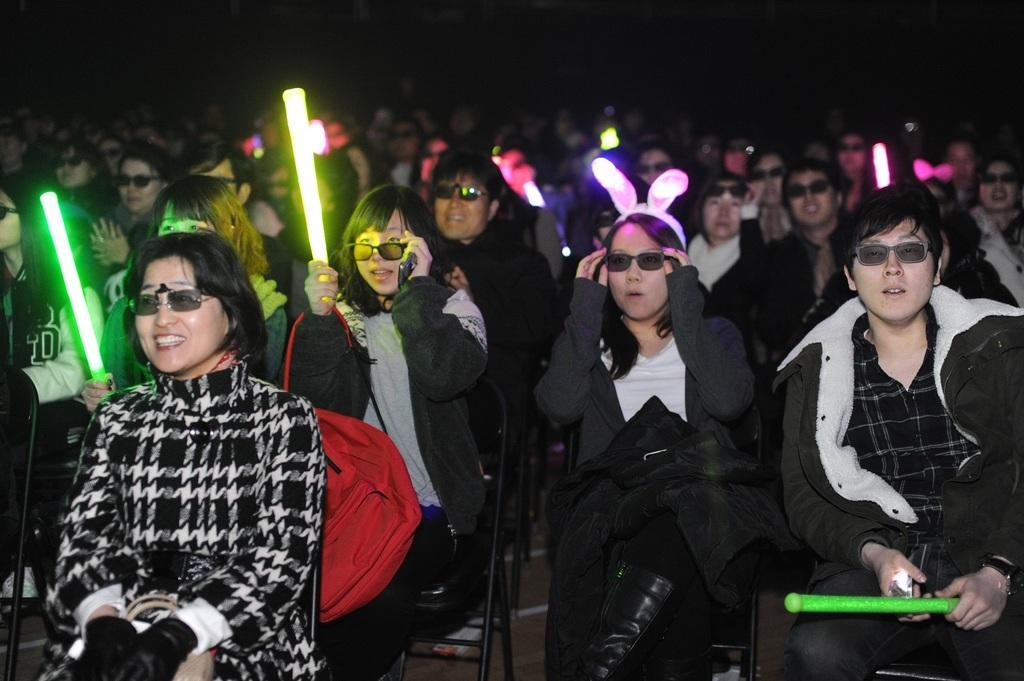What are the people in the image doing? The people in the image are sitting on chairs. What objects are the people holding in their hands? Some people are holding radium lights in their hands. What can be observed about the lighting conditions in the image? The background of the image is dark. What type of rock is being used as a selection tool in the image? There is no rock present in the image, nor is there any indication of a selection tool being used. 